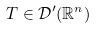Convert formula to latex. <formula><loc_0><loc_0><loc_500><loc_500>T \in { \mathcal { D } } ^ { \prime } ( \mathbb { R } ^ { n } )</formula> 